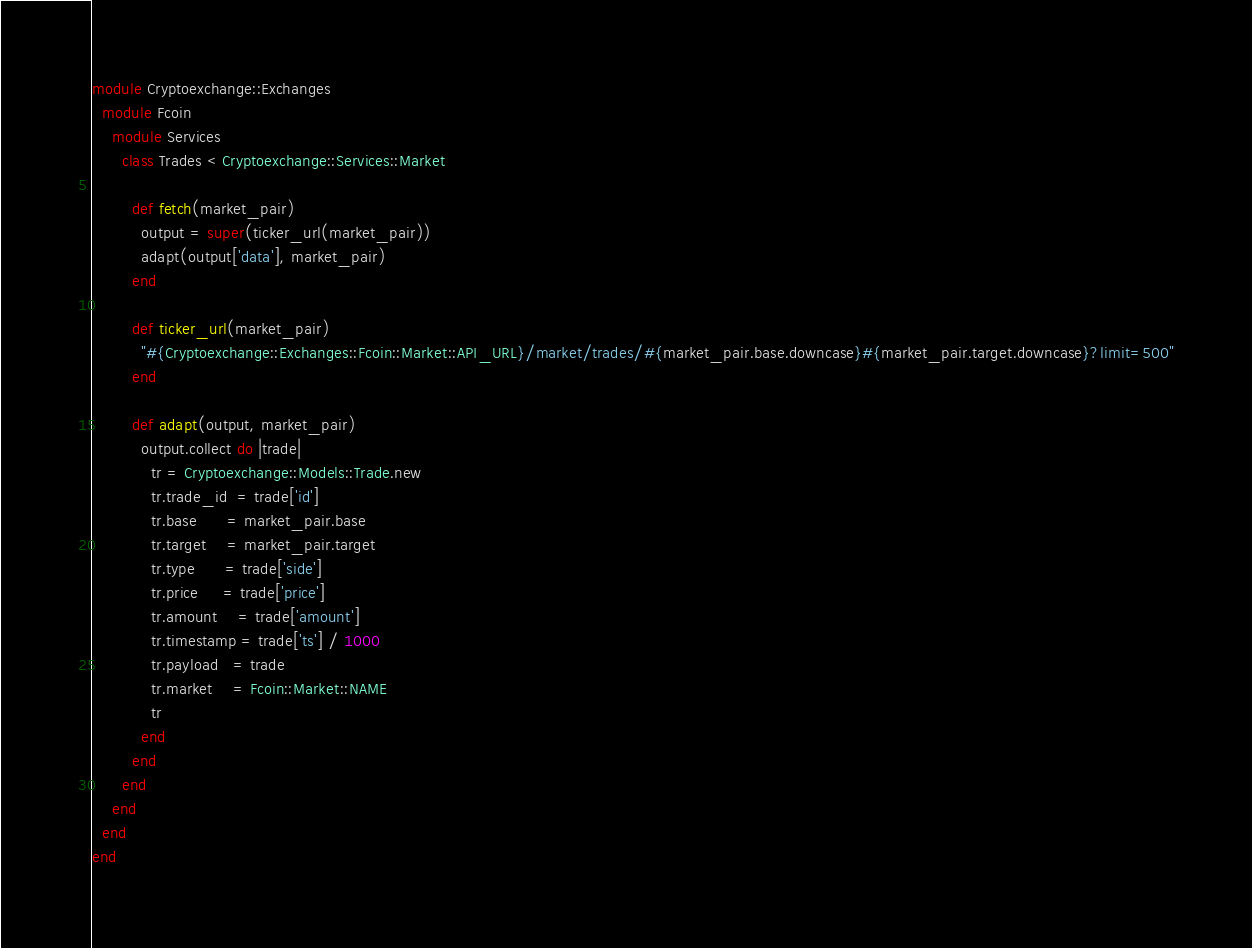<code> <loc_0><loc_0><loc_500><loc_500><_Ruby_>module Cryptoexchange::Exchanges
  module Fcoin
    module Services
      class Trades < Cryptoexchange::Services::Market

        def fetch(market_pair)
          output = super(ticker_url(market_pair))
          adapt(output['data'], market_pair)
        end

        def ticker_url(market_pair)
          "#{Cryptoexchange::Exchanges::Fcoin::Market::API_URL}/market/trades/#{market_pair.base.downcase}#{market_pair.target.downcase}?limit=500"
        end

        def adapt(output, market_pair)
          output.collect do |trade|
            tr = Cryptoexchange::Models::Trade.new
            tr.trade_id  = trade['id']
            tr.base      = market_pair.base
            tr.target    = market_pair.target
            tr.type      = trade['side']
            tr.price     = trade['price']
            tr.amount    = trade['amount']
            tr.timestamp = trade['ts'] / 1000
            tr.payload   = trade
            tr.market    = Fcoin::Market::NAME
            tr
          end
        end
      end
    end
  end
end
</code> 